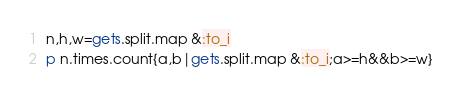<code> <loc_0><loc_0><loc_500><loc_500><_Ruby_>n,h,w=gets.split.map &:to_i
p n.times.count{a,b|gets.split.map &:to_i;a>=h&&b>=w}</code> 